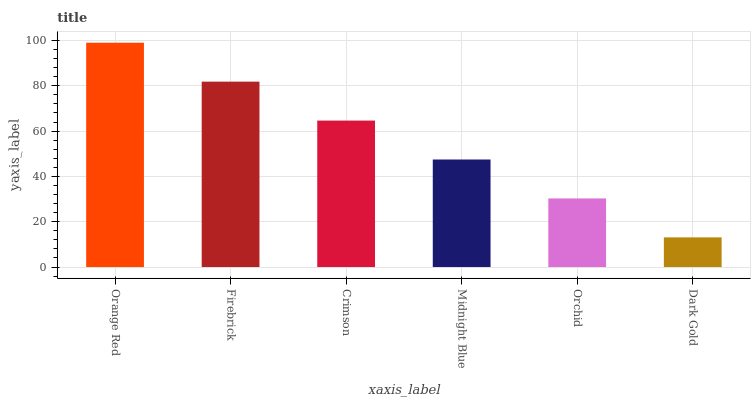Is Dark Gold the minimum?
Answer yes or no. Yes. Is Orange Red the maximum?
Answer yes or no. Yes. Is Firebrick the minimum?
Answer yes or no. No. Is Firebrick the maximum?
Answer yes or no. No. Is Orange Red greater than Firebrick?
Answer yes or no. Yes. Is Firebrick less than Orange Red?
Answer yes or no. Yes. Is Firebrick greater than Orange Red?
Answer yes or no. No. Is Orange Red less than Firebrick?
Answer yes or no. No. Is Crimson the high median?
Answer yes or no. Yes. Is Midnight Blue the low median?
Answer yes or no. Yes. Is Midnight Blue the high median?
Answer yes or no. No. Is Crimson the low median?
Answer yes or no. No. 